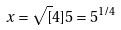<formula> <loc_0><loc_0><loc_500><loc_500>x = \sqrt { [ } 4 ] { 5 } = 5 ^ { 1 / 4 }</formula> 